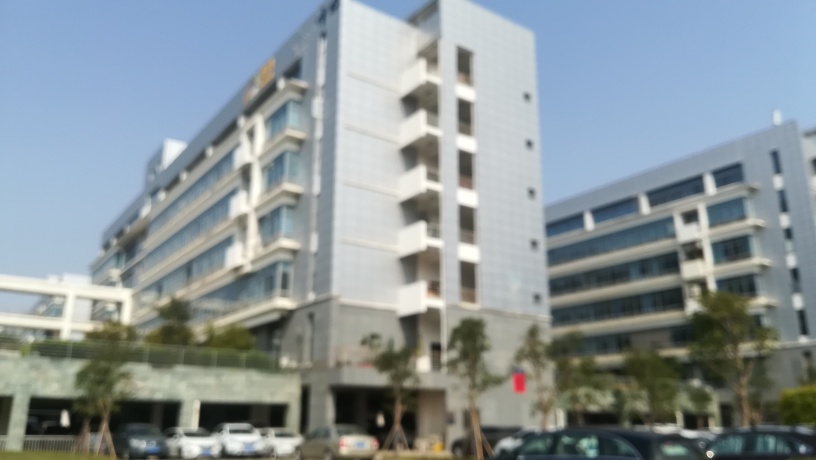What can we deduce about the weather in the image? The bright lighting and absence of visible clouds suggests that the image was taken on a clear day. The shadows cast by the building and cars are sharp, which is typical of sunny weather conditions. 